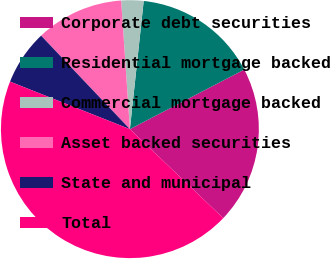<chart> <loc_0><loc_0><loc_500><loc_500><pie_chart><fcel>Corporate debt securities<fcel>Residential mortgage backed<fcel>Commercial mortgage backed<fcel>Asset backed securities<fcel>State and municipal<fcel>Total<nl><fcel>19.76%<fcel>15.65%<fcel>2.79%<fcel>11.01%<fcel>6.9%<fcel>43.9%<nl></chart> 